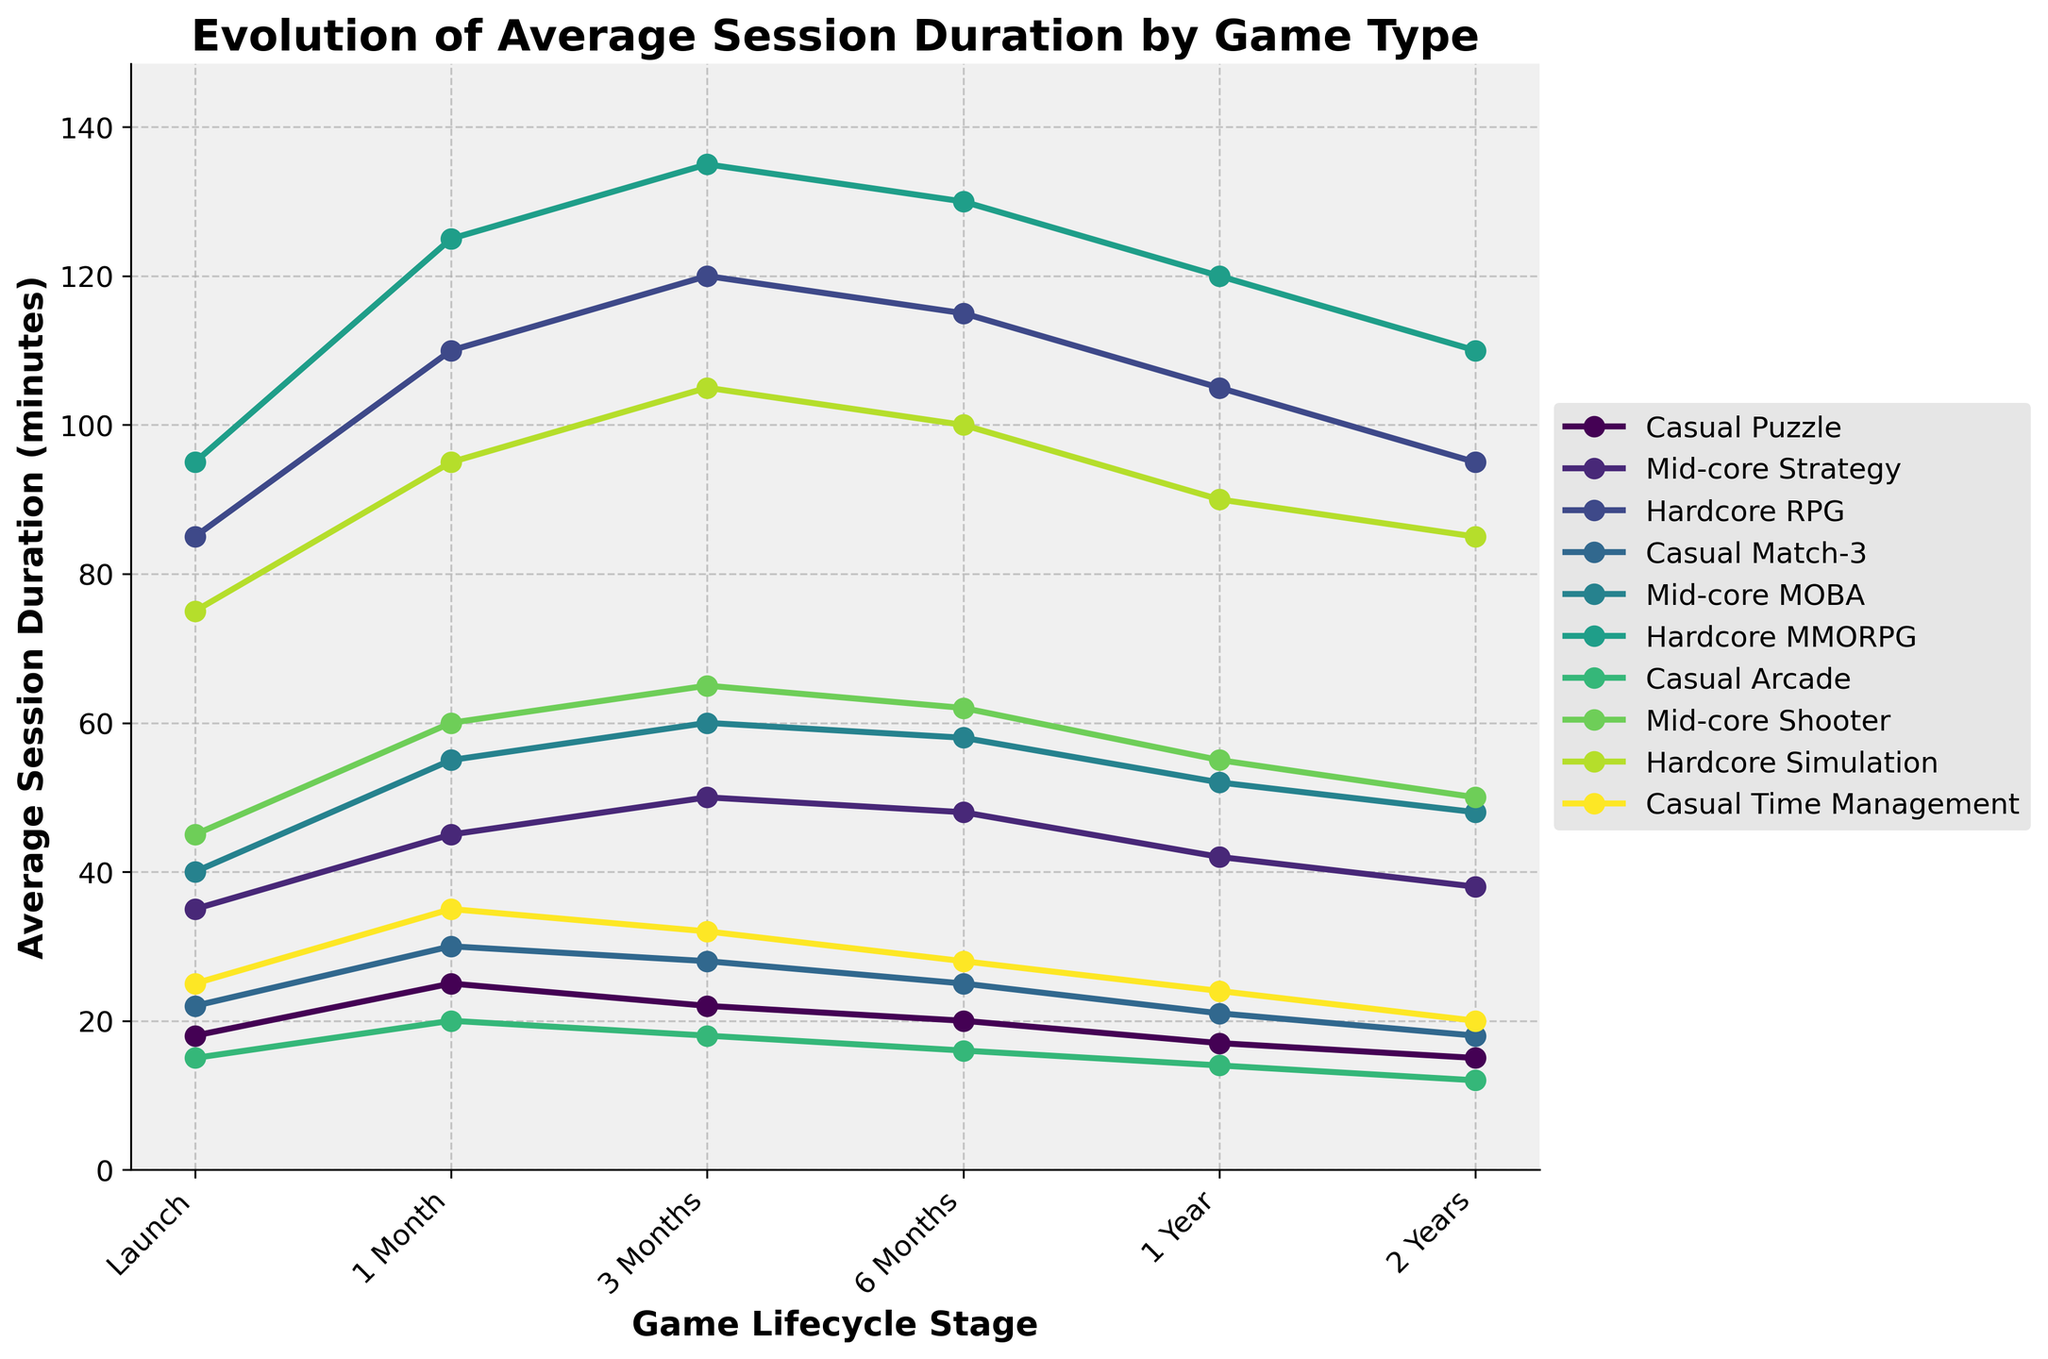What game type has the highest average session duration at the 1-month mark? To find the game type with the highest session duration at the 1-month mark, look at the second column of the line plot. Find and identify the highest point at the 1-month mark and check its corresponding game type label.
Answer: Hardcore MMORPG How does the average session duration of Casual Puzzle change from launch to 1 year? Identify the points for Casual Puzzle on the plot at the launch (18 minutes) and at 1 year (17 minutes). Subtract the session duration at launch from the session duration after 1 year.
Answer: Decreases by 1 minute Compare the session duration trends of Mid-core MOBA and Hardcore RPG over 6 months. Which one shows a larger decrease? Check the session durations at launch (Mid-core MOBA: 40, Hardcore RPG: 85), at 6 months (Mid-core MOBA: 58, Hardcore RPG: 115). Calculate the decrease by subtracting values at 6 months from their respective launch values. Compare the resulting decreases.
Answer: Hardcore RPG Which game type has the most stable session duration over the 2-year period? To determine the most stable game type, calculate the range (max - min) of session durations over all stages for each game type. The smallest range indicates the most stable game type.
Answer: Casual Arcade What is the average session duration of Hardcore Simulation across all lifecycle stages? Add the session durations of Hardcore Simulation at all lifecycle stages and divide the sum by the number of stages: (75+95+105+100+90+85) / 6.
Answer: 91.7 minutes Between Casual Match-3 and Casual Time Management, which game type has a higher session duration at the 3-month mark, and by how much? Identify the session durations at the 3-month mark (Casual Match-3: 28, Casual Time Management: 32). Subtract the session duration of Casual Match-3 from Casual Time Management.
Answer: Casual Time Management by 4 minutes Does the session duration for any game type increase between the 6-month and 2-year marks? Look at the plot for each game type and compare values at 6 months and 2 years. Check if any game type shows an increase.
Answer: No What is the difference in session duration between Mid-core Shooter and Hardcore MMORPG at the launch stage? Identify the session durations for Mid-core Shooter (45 minutes) and Hardcore MMORPG (95 minutes) at launch. Subtract the session duration of Mid-core Shooter from Hardcore MMORPG.
Answer: 50 minutes Compare the trends of session duration for Casual Arcade and Casual Puzzle. Which game type has a steeper decline over the game's lifecycle? Calculate the overall decline in session duration by subtracting the 2-year value from the launch value for both game types (Casual Arcade decline: 15-12=3, Casual Puzzle decline: 18-15=3).
Answer: Equal decline What is the total session duration for all casual games at the 1-year mark? Identify the session durations for all casual games at the 1-year mark (Casual Puzzle: 17, Casual Match-3: 21, Casual Arcade: 14, Casual Time Management: 24). Sum these values.
Answer: 76 minutes 